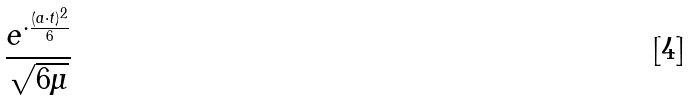<formula> <loc_0><loc_0><loc_500><loc_500>\frac { e ^ { \cdot \frac { ( a \cdot t ) ^ { 2 } } { 6 } } } { \sqrt { 6 \mu } }</formula> 